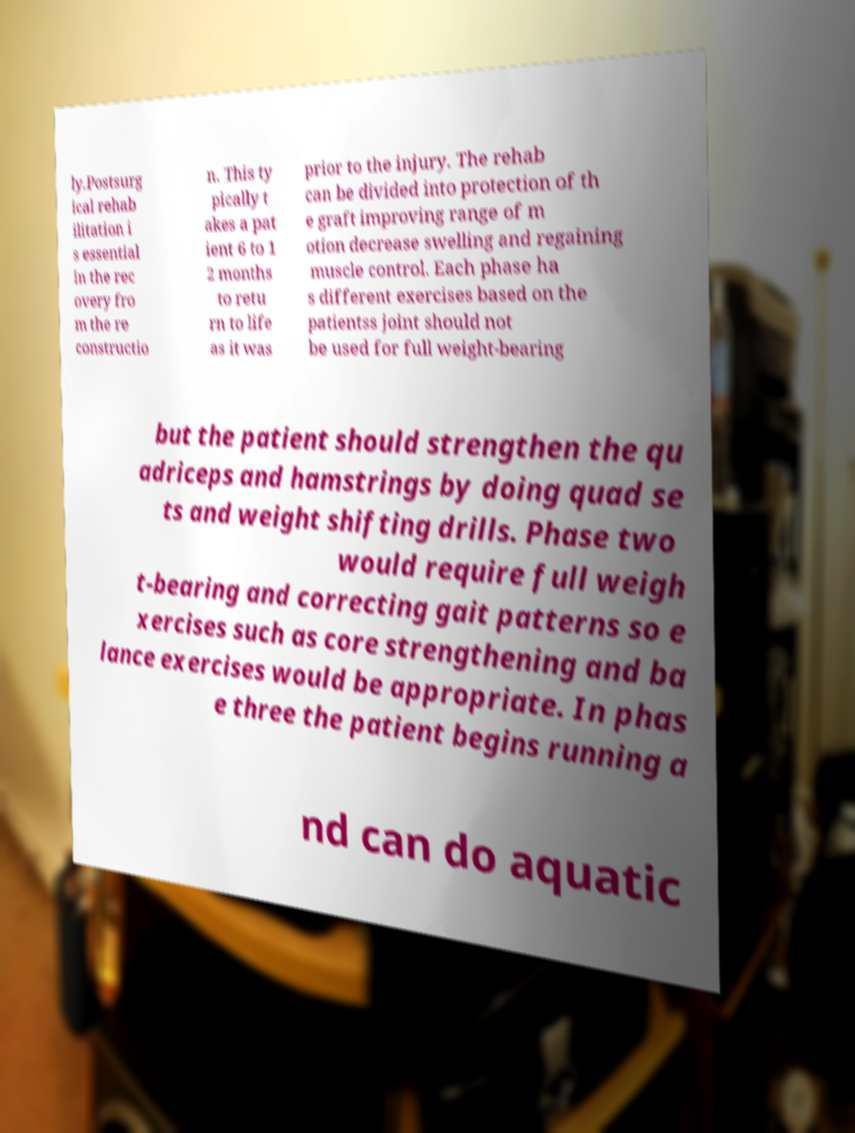For documentation purposes, I need the text within this image transcribed. Could you provide that? ly.Postsurg ical rehab ilitation i s essential in the rec overy fro m the re constructio n. This ty pically t akes a pat ient 6 to 1 2 months to retu rn to life as it was prior to the injury. The rehab can be divided into protection of th e graft improving range of m otion decrease swelling and regaining muscle control. Each phase ha s different exercises based on the patientss joint should not be used for full weight-bearing but the patient should strengthen the qu adriceps and hamstrings by doing quad se ts and weight shifting drills. Phase two would require full weigh t-bearing and correcting gait patterns so e xercises such as core strengthening and ba lance exercises would be appropriate. In phas e three the patient begins running a nd can do aquatic 